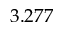Convert formula to latex. <formula><loc_0><loc_0><loc_500><loc_500>3 . 2 7 7</formula> 